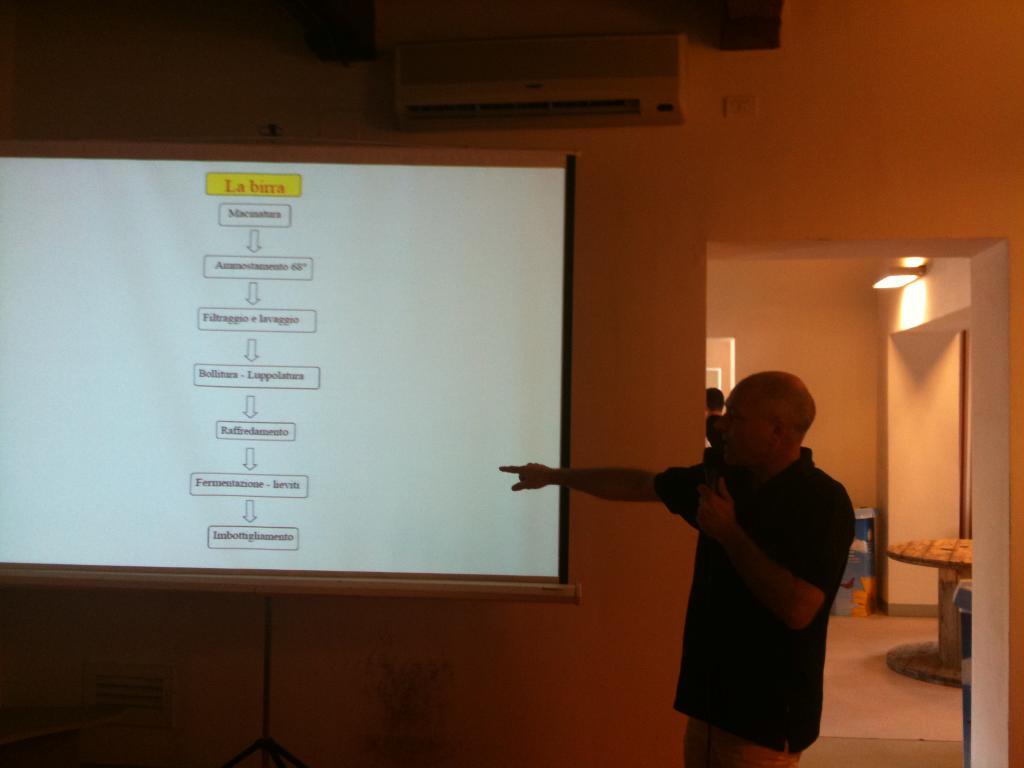What is the subject of this man's powerpoint presentation?
Keep it short and to the point. La birra. What does it say in the yellow box on the screen?
Offer a very short reply. La birra. 